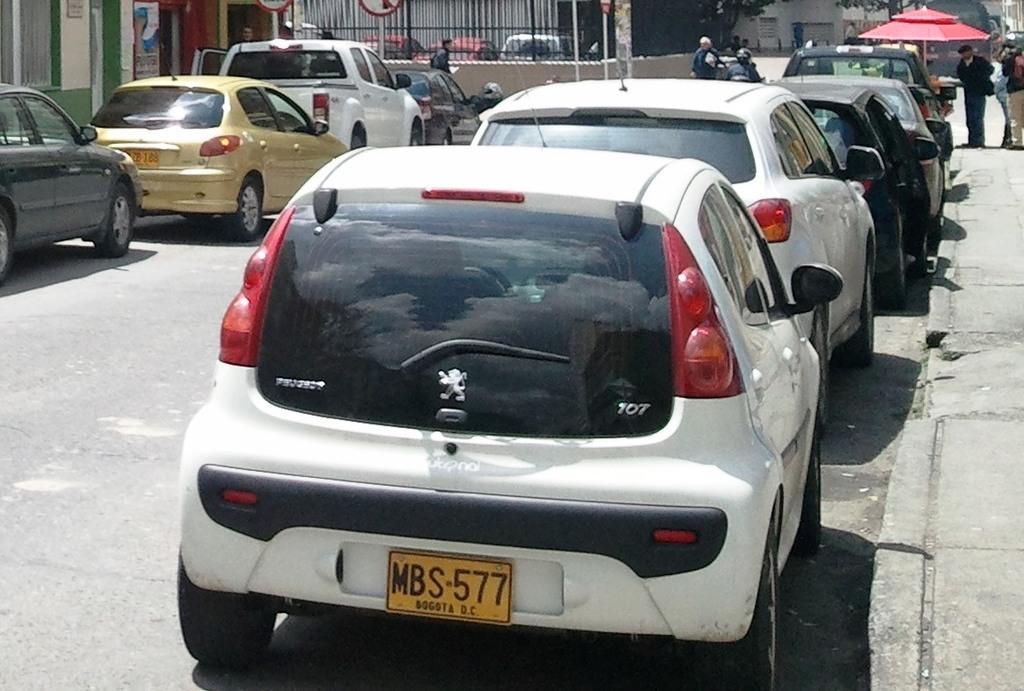Can you describe this image briefly? In this image I can see fleets of cars on the road, umbrella hut and a crowd. On the top I can see a fence and trees. This image is taken during a day on the road. 